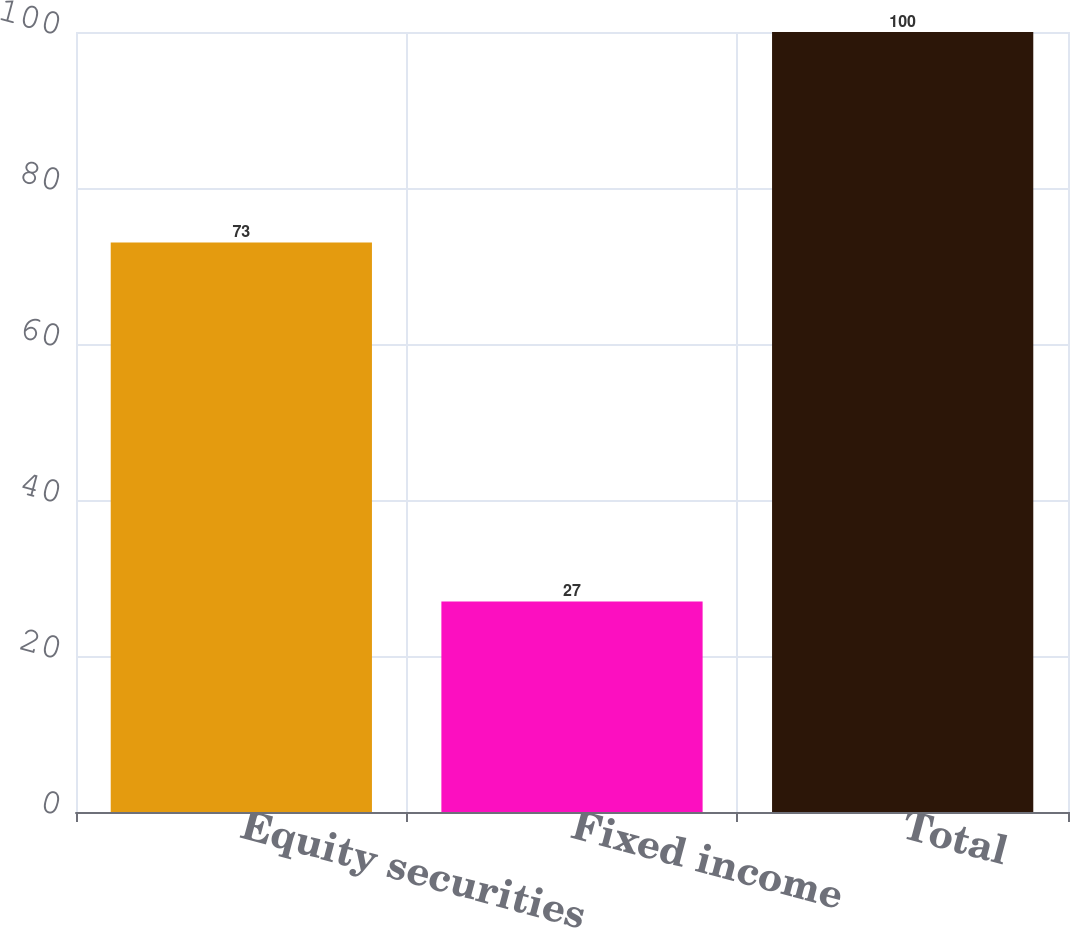<chart> <loc_0><loc_0><loc_500><loc_500><bar_chart><fcel>Equity securities<fcel>Fixed income<fcel>Total<nl><fcel>73<fcel>27<fcel>100<nl></chart> 